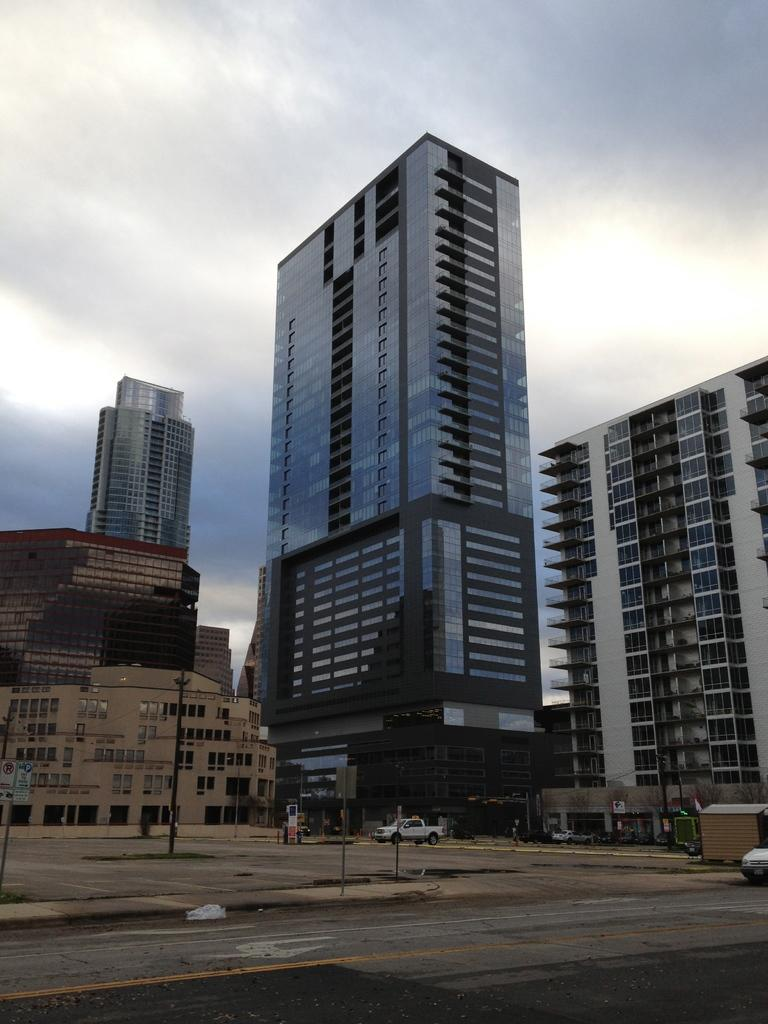What type of structures can be seen in the image? There are buildings in the image. What is located in front of the buildings? There are vehicles and poles in front of the buildings. What can be seen in the background behind the vehicles? The sky is visible behind the vehicles. How many nerves can be seen connecting the buildings in the image? There are no nerves visible in the image; it features buildings, vehicles, poles, and the sky. What type of bird is perched on the wren in the image? There is no wren present in the image, and therefore no bird can be perched on it. 